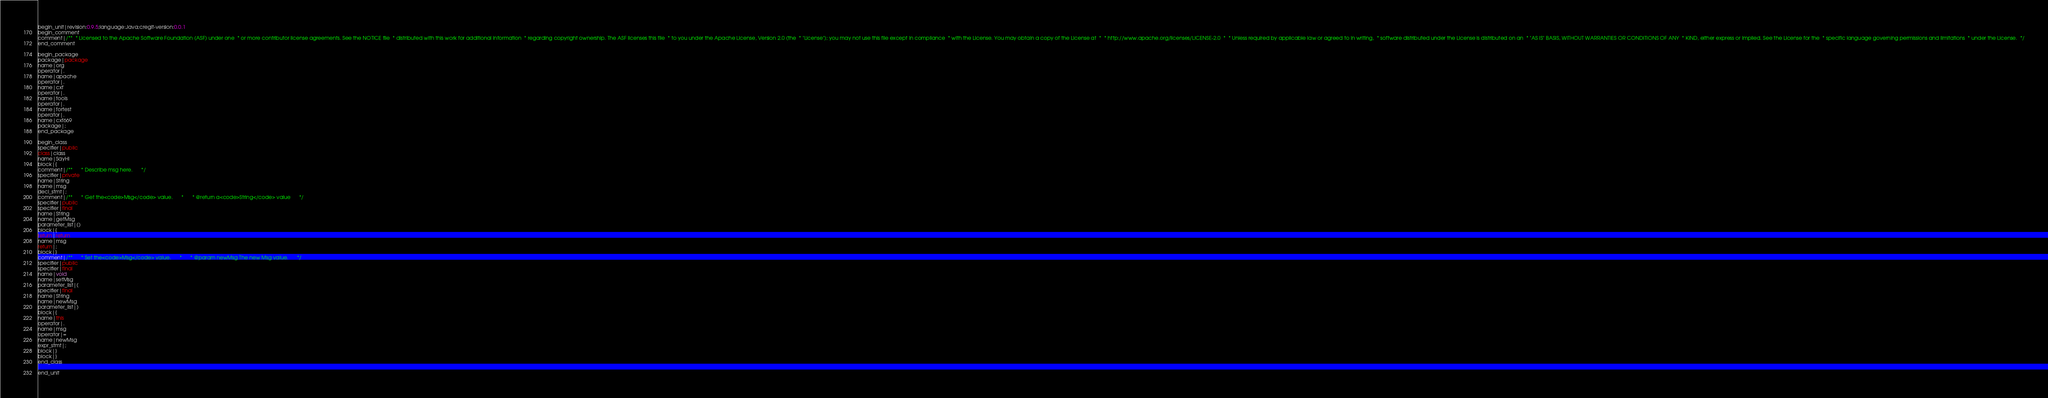Convert code to text. <code><loc_0><loc_0><loc_500><loc_500><_Java_>begin_unit|revision:0.9.5;language:Java;cregit-version:0.0.1
begin_comment
comment|/**  * Licensed to the Apache Software Foundation (ASF) under one  * or more contributor license agreements. See the NOTICE file  * distributed with this work for additional information  * regarding copyright ownership. The ASF licenses this file  * to you under the Apache License, Version 2.0 (the  * "License"); you may not use this file except in compliance  * with the License. You may obtain a copy of the License at  *  * http://www.apache.org/licenses/LICENSE-2.0  *  * Unless required by applicable law or agreed to in writing,  * software distributed under the License is distributed on an  * "AS IS" BASIS, WITHOUT WARRANTIES OR CONDITIONS OF ANY  * KIND, either express or implied. See the License for the  * specific language governing permissions and limitations  * under the License.  */
end_comment

begin_package
package|package
name|org
operator|.
name|apache
operator|.
name|cxf
operator|.
name|tools
operator|.
name|fortest
operator|.
name|cxf669
package|;
end_package

begin_class
specifier|public
class|class
name|SayHi
block|{
comment|/**      * Describe msg here.      */
specifier|private
name|String
name|msg
decl_stmt|;
comment|/**      * Get the<code>Msg</code> value.      *      * @return a<code>String</code> value      */
specifier|public
specifier|final
name|String
name|getMsg
parameter_list|()
block|{
return|return
name|msg
return|;
block|}
comment|/**      * Set the<code>Msg</code> value.      *      * @param newMsg The new Msg value.      */
specifier|public
specifier|final
name|void
name|setMsg
parameter_list|(
specifier|final
name|String
name|newMsg
parameter_list|)
block|{
name|this
operator|.
name|msg
operator|=
name|newMsg
expr_stmt|;
block|}
block|}
end_class

end_unit

</code> 